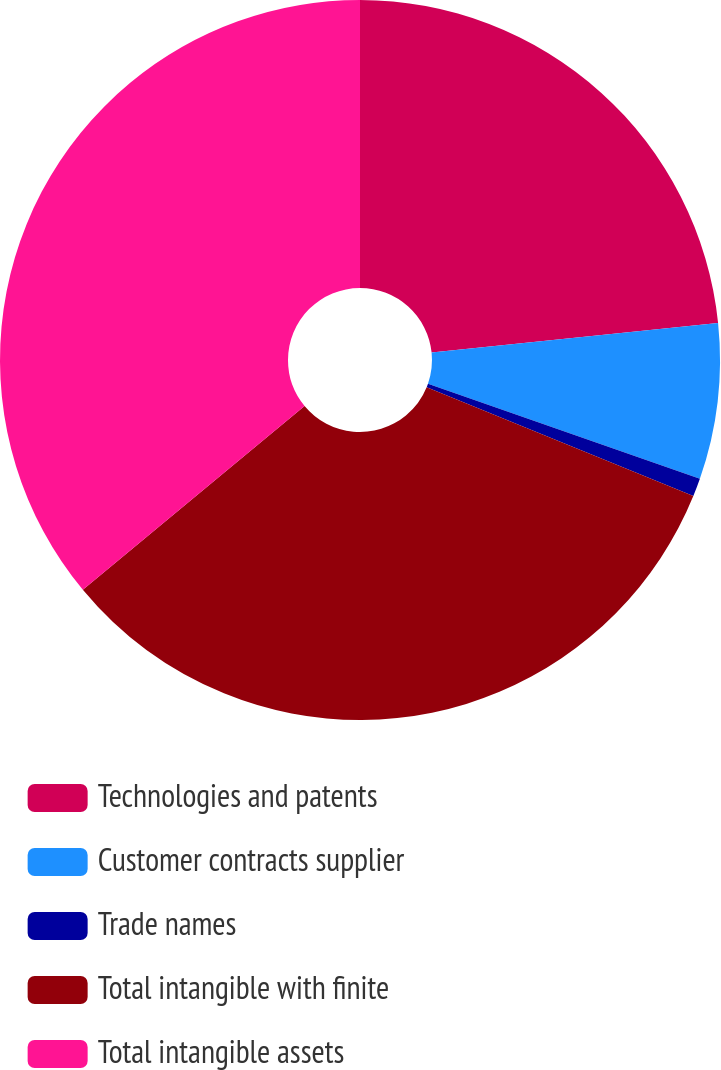Convert chart to OTSL. <chart><loc_0><loc_0><loc_500><loc_500><pie_chart><fcel>Technologies and patents<fcel>Customer contracts supplier<fcel>Trade names<fcel>Total intangible with finite<fcel>Total intangible assets<nl><fcel>23.36%<fcel>6.99%<fcel>0.82%<fcel>32.82%<fcel>36.02%<nl></chart> 